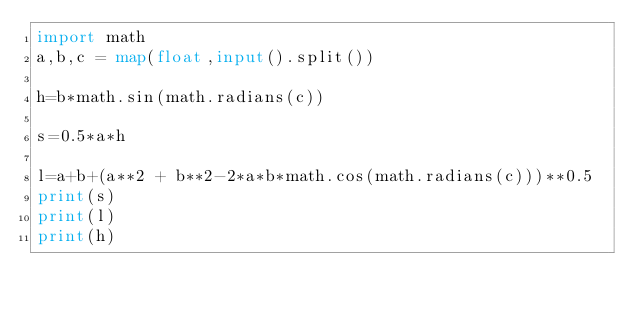Convert code to text. <code><loc_0><loc_0><loc_500><loc_500><_Python_>import math
a,b,c = map(float,input().split())

h=b*math.sin(math.radians(c))

s=0.5*a*h

l=a+b+(a**2 + b**2-2*a*b*math.cos(math.radians(c)))**0.5
print(s)
print(l)
print(h)


</code> 